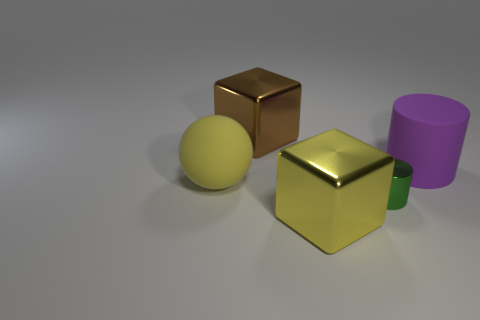There is a purple matte thing that is the same shape as the small green shiny object; what size is it?
Offer a terse response. Large. Is there any other thing that has the same size as the matte ball?
Your answer should be compact. Yes. What material is the big cube in front of the large block that is behind the large purple cylinder?
Your answer should be compact. Metal. How many rubber objects are large gray cylinders or big yellow objects?
Your answer should be compact. 1. What is the color of the other object that is the same shape as the tiny green shiny thing?
Offer a terse response. Purple. How many other large rubber cylinders have the same color as the rubber cylinder?
Your answer should be compact. 0. There is a big metallic cube that is in front of the brown block; are there any large brown blocks that are right of it?
Your answer should be very brief. No. What number of things are both in front of the matte cylinder and right of the rubber sphere?
Your answer should be compact. 2. What number of tiny green cylinders have the same material as the sphere?
Offer a very short reply. 0. How big is the cube that is to the right of the big shiny cube that is behind the large purple object?
Provide a succinct answer. Large. 